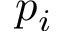<formula> <loc_0><loc_0><loc_500><loc_500>p _ { i }</formula> 